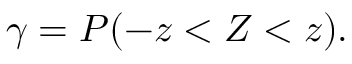<formula> <loc_0><loc_0><loc_500><loc_500>\gamma = P ( - z < Z < z ) .</formula> 